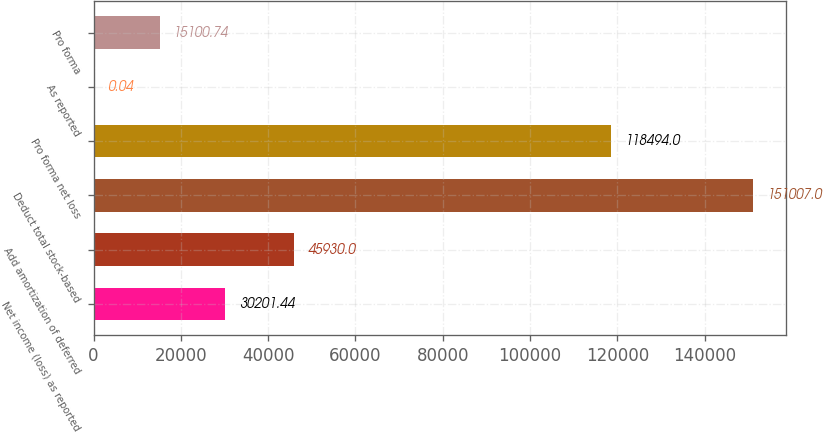Convert chart. <chart><loc_0><loc_0><loc_500><loc_500><bar_chart><fcel>Net income (loss) as reported<fcel>Add amortization of deferred<fcel>Deduct total stock-based<fcel>Pro forma net loss<fcel>As reported<fcel>Pro forma<nl><fcel>30201.4<fcel>45930<fcel>151007<fcel>118494<fcel>0.04<fcel>15100.7<nl></chart> 